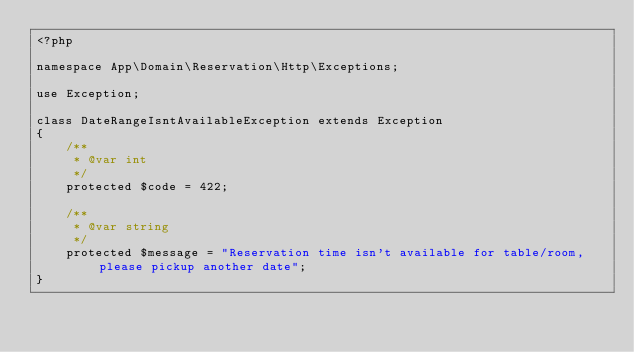Convert code to text. <code><loc_0><loc_0><loc_500><loc_500><_PHP_><?php

namespace App\Domain\Reservation\Http\Exceptions;

use Exception;

class DateRangeIsntAvailableException extends Exception
{
    /**
     * @var int
     */
    protected $code = 422;

    /**
     * @var string
     */
    protected $message = "Reservation time isn't available for table/room, please pickup another date";
}
</code> 